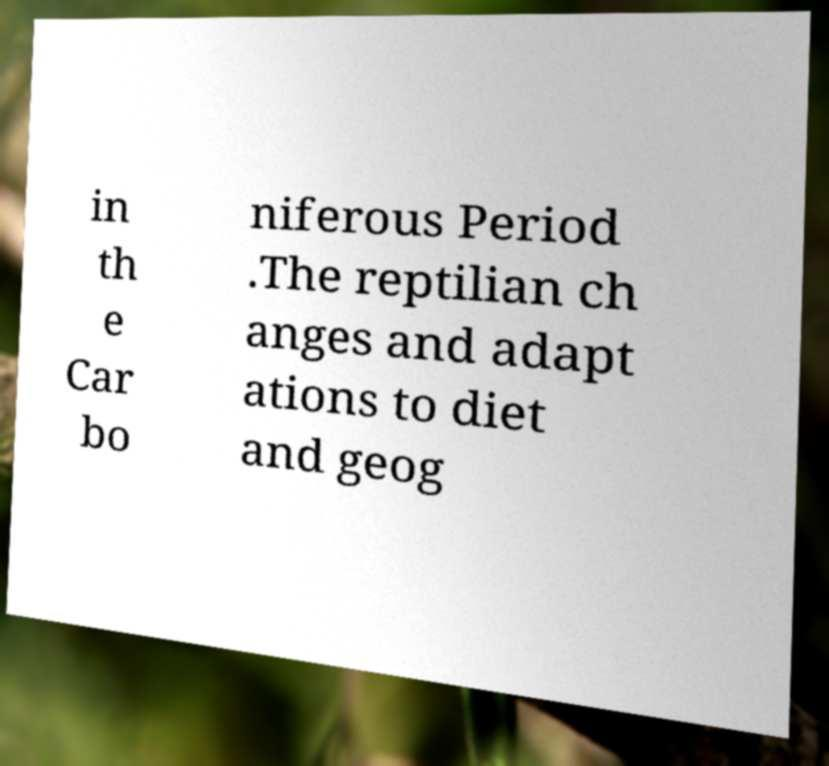Could you extract and type out the text from this image? in th e Car bo niferous Period .The reptilian ch anges and adapt ations to diet and geog 